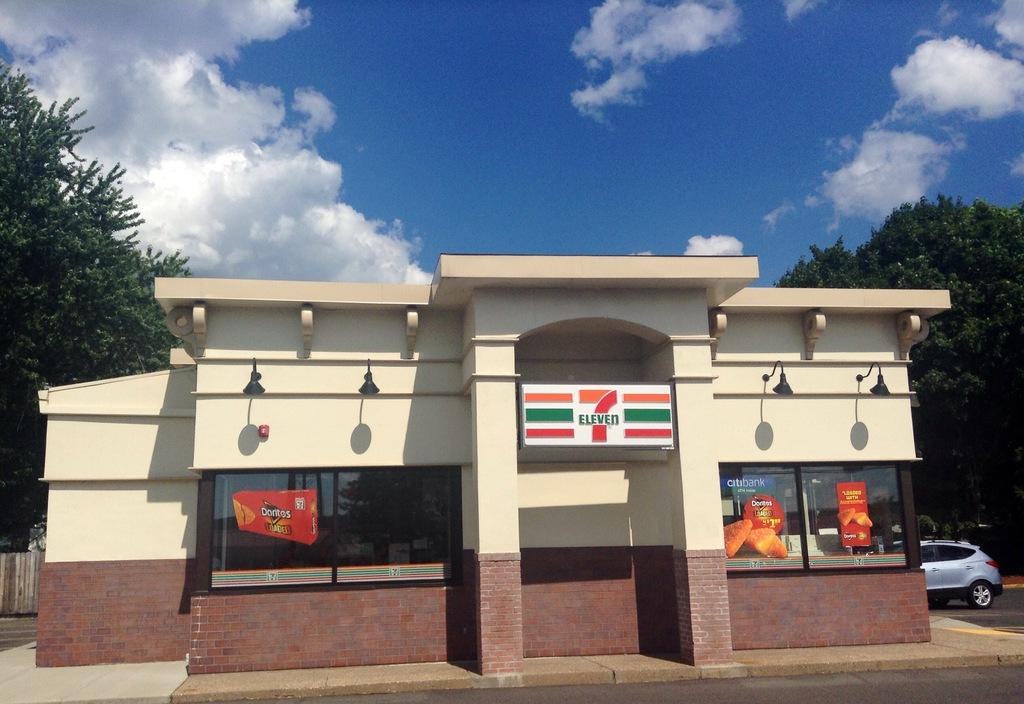What type of structure is visible in the image? There is a building in the image. What is attached to the building? There is a name board on the building. What type of vegetation can be seen in the image? There are trees in the image. What mode of transportation is present in the image? There is a vehicle in the image. What type of illumination is present on the building? Lights are attached to the wall of the building. What can be seen in the sky in the image? There are clouds in the sky. What type of beast can be seen using its teeth to dig a hole in the image? There is no beast present in the image, and therefore no such activity can be observed. What type of gardening tool is visible in the image? There is no gardening tool, such as a spade, present in the image. 